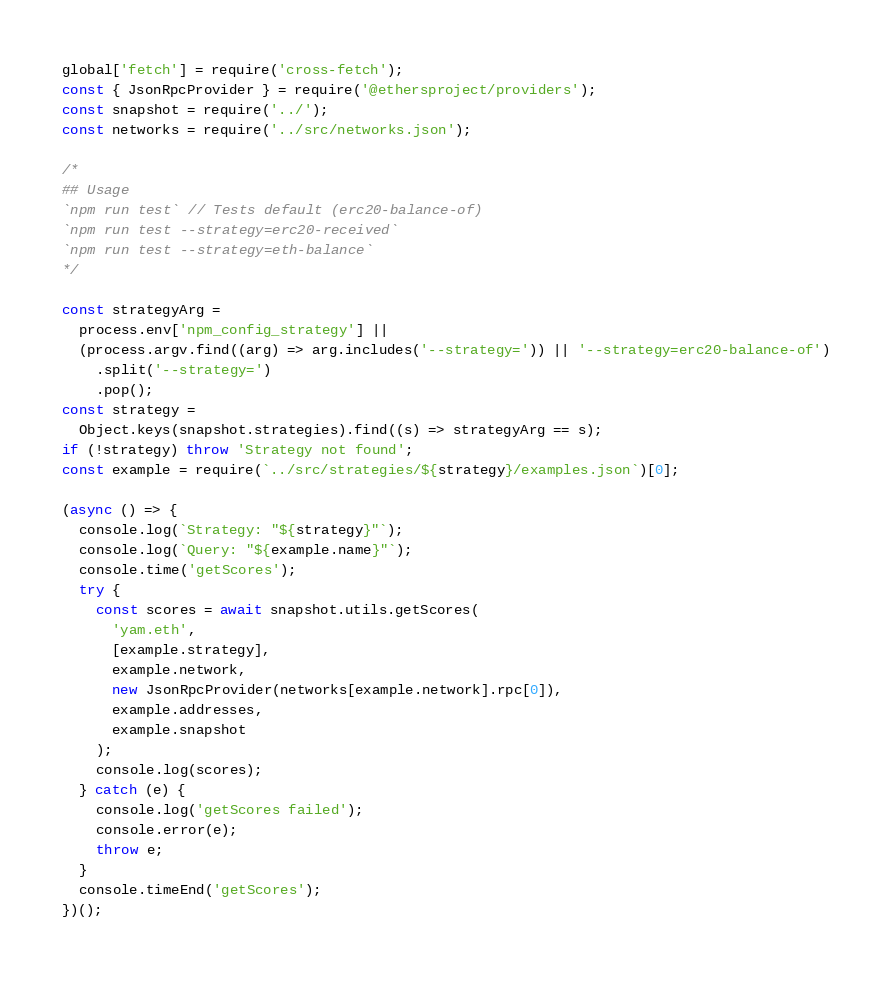Convert code to text. <code><loc_0><loc_0><loc_500><loc_500><_TypeScript_>global['fetch'] = require('cross-fetch');
const { JsonRpcProvider } = require('@ethersproject/providers');
const snapshot = require('../');
const networks = require('../src/networks.json');

/*
## Usage
`npm run test` // Tests default (erc20-balance-of)
`npm run test --strategy=erc20-received`
`npm run test --strategy=eth-balance`
*/

const strategyArg =
  process.env['npm_config_strategy'] ||
  (process.argv.find((arg) => arg.includes('--strategy=')) || '--strategy=erc20-balance-of')
    .split('--strategy=')
    .pop();
const strategy =
  Object.keys(snapshot.strategies).find((s) => strategyArg == s);
if (!strategy) throw 'Strategy not found';
const example = require(`../src/strategies/${strategy}/examples.json`)[0];

(async () => {
  console.log(`Strategy: "${strategy}"`);
  console.log(`Query: "${example.name}"`);
  console.time('getScores');
  try {
    const scores = await snapshot.utils.getScores(
      'yam.eth',
      [example.strategy],
      example.network,
      new JsonRpcProvider(networks[example.network].rpc[0]),
      example.addresses,
      example.snapshot
    );
    console.log(scores);
  } catch (e) {
    console.log('getScores failed');
    console.error(e);
    throw e;
  }
  console.timeEnd('getScores');
})();
</code> 